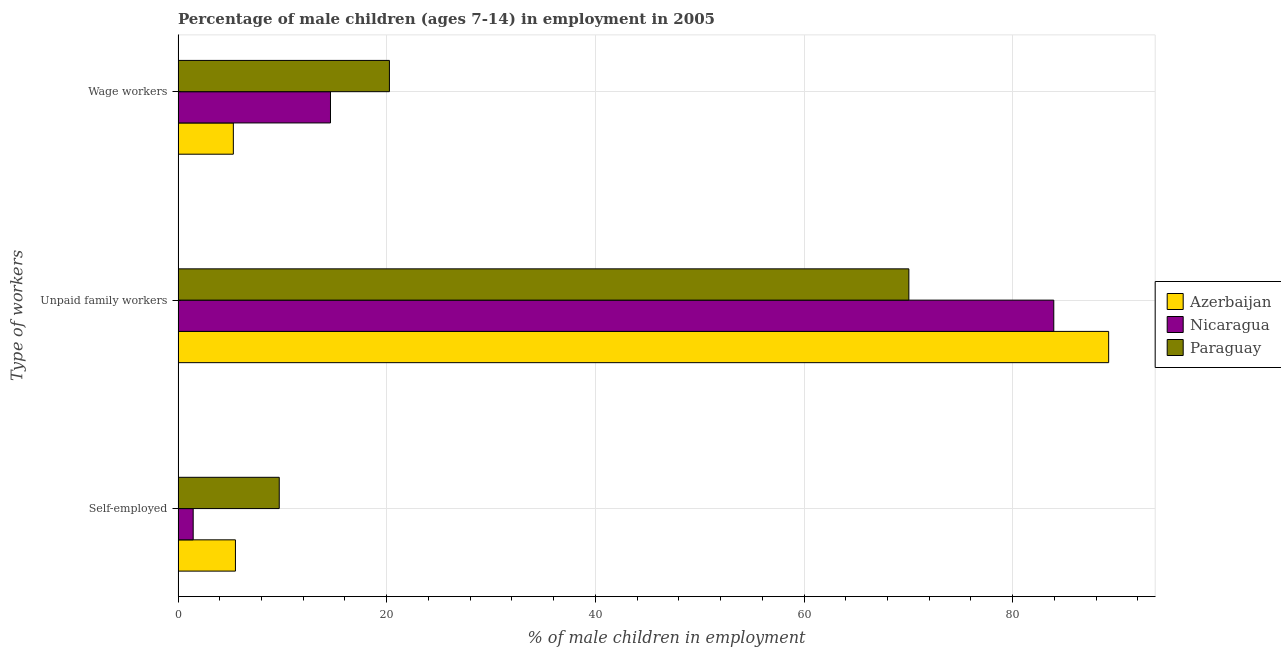How many different coloured bars are there?
Your response must be concise. 3. Are the number of bars per tick equal to the number of legend labels?
Offer a very short reply. Yes. Are the number of bars on each tick of the Y-axis equal?
Provide a short and direct response. Yes. How many bars are there on the 3rd tick from the bottom?
Offer a very short reply. 3. What is the label of the 1st group of bars from the top?
Provide a short and direct response. Wage workers. What is the percentage of children employed as unpaid family workers in Azerbaijan?
Offer a terse response. 89.2. Across all countries, what is the maximum percentage of children employed as unpaid family workers?
Your answer should be compact. 89.2. Across all countries, what is the minimum percentage of self employed children?
Your response must be concise. 1.45. In which country was the percentage of self employed children maximum?
Offer a terse response. Paraguay. In which country was the percentage of children employed as wage workers minimum?
Keep it short and to the point. Azerbaijan. What is the total percentage of children employed as wage workers in the graph?
Give a very brief answer. 40.17. What is the difference between the percentage of children employed as unpaid family workers in Paraguay and that in Nicaragua?
Provide a succinct answer. -13.89. What is the difference between the percentage of children employed as wage workers in Paraguay and the percentage of self employed children in Azerbaijan?
Provide a succinct answer. 14.76. What is the average percentage of self employed children per country?
Provide a short and direct response. 5.55. What is the difference between the percentage of children employed as wage workers and percentage of self employed children in Nicaragua?
Ensure brevity in your answer.  13.16. In how many countries, is the percentage of children employed as wage workers greater than 28 %?
Offer a terse response. 0. What is the ratio of the percentage of children employed as unpaid family workers in Paraguay to that in Azerbaijan?
Your response must be concise. 0.79. Is the difference between the percentage of children employed as unpaid family workers in Azerbaijan and Paraguay greater than the difference between the percentage of self employed children in Azerbaijan and Paraguay?
Keep it short and to the point. Yes. What is the difference between the highest and the second highest percentage of self employed children?
Provide a succinct answer. 4.2. What is the difference between the highest and the lowest percentage of children employed as wage workers?
Your answer should be compact. 14.96. What does the 3rd bar from the top in Unpaid family workers represents?
Your response must be concise. Azerbaijan. What does the 1st bar from the bottom in Self-employed represents?
Ensure brevity in your answer.  Azerbaijan. Is it the case that in every country, the sum of the percentage of self employed children and percentage of children employed as unpaid family workers is greater than the percentage of children employed as wage workers?
Your answer should be very brief. Yes. Are all the bars in the graph horizontal?
Provide a succinct answer. Yes. Are the values on the major ticks of X-axis written in scientific E-notation?
Your answer should be compact. No. Where does the legend appear in the graph?
Provide a short and direct response. Center right. What is the title of the graph?
Your answer should be compact. Percentage of male children (ages 7-14) in employment in 2005. Does "Bhutan" appear as one of the legend labels in the graph?
Your answer should be very brief. No. What is the label or title of the X-axis?
Make the answer very short. % of male children in employment. What is the label or title of the Y-axis?
Make the answer very short. Type of workers. What is the % of male children in employment in Nicaragua in Self-employed?
Provide a succinct answer. 1.45. What is the % of male children in employment in Azerbaijan in Unpaid family workers?
Offer a terse response. 89.2. What is the % of male children in employment in Nicaragua in Unpaid family workers?
Keep it short and to the point. 83.94. What is the % of male children in employment in Paraguay in Unpaid family workers?
Offer a terse response. 70.05. What is the % of male children in employment in Azerbaijan in Wage workers?
Offer a very short reply. 5.3. What is the % of male children in employment of Nicaragua in Wage workers?
Ensure brevity in your answer.  14.61. What is the % of male children in employment in Paraguay in Wage workers?
Keep it short and to the point. 20.26. Across all Type of workers, what is the maximum % of male children in employment of Azerbaijan?
Provide a succinct answer. 89.2. Across all Type of workers, what is the maximum % of male children in employment of Nicaragua?
Keep it short and to the point. 83.94. Across all Type of workers, what is the maximum % of male children in employment in Paraguay?
Offer a very short reply. 70.05. Across all Type of workers, what is the minimum % of male children in employment in Azerbaijan?
Give a very brief answer. 5.3. Across all Type of workers, what is the minimum % of male children in employment of Nicaragua?
Provide a short and direct response. 1.45. What is the total % of male children in employment in Paraguay in the graph?
Provide a short and direct response. 100.01. What is the difference between the % of male children in employment of Azerbaijan in Self-employed and that in Unpaid family workers?
Ensure brevity in your answer.  -83.7. What is the difference between the % of male children in employment of Nicaragua in Self-employed and that in Unpaid family workers?
Your answer should be compact. -82.49. What is the difference between the % of male children in employment in Paraguay in Self-employed and that in Unpaid family workers?
Your response must be concise. -60.35. What is the difference between the % of male children in employment of Nicaragua in Self-employed and that in Wage workers?
Keep it short and to the point. -13.16. What is the difference between the % of male children in employment of Paraguay in Self-employed and that in Wage workers?
Make the answer very short. -10.56. What is the difference between the % of male children in employment of Azerbaijan in Unpaid family workers and that in Wage workers?
Ensure brevity in your answer.  83.9. What is the difference between the % of male children in employment in Nicaragua in Unpaid family workers and that in Wage workers?
Your answer should be very brief. 69.33. What is the difference between the % of male children in employment of Paraguay in Unpaid family workers and that in Wage workers?
Your answer should be very brief. 49.79. What is the difference between the % of male children in employment in Azerbaijan in Self-employed and the % of male children in employment in Nicaragua in Unpaid family workers?
Give a very brief answer. -78.44. What is the difference between the % of male children in employment in Azerbaijan in Self-employed and the % of male children in employment in Paraguay in Unpaid family workers?
Offer a terse response. -64.55. What is the difference between the % of male children in employment of Nicaragua in Self-employed and the % of male children in employment of Paraguay in Unpaid family workers?
Provide a succinct answer. -68.6. What is the difference between the % of male children in employment of Azerbaijan in Self-employed and the % of male children in employment of Nicaragua in Wage workers?
Give a very brief answer. -9.11. What is the difference between the % of male children in employment of Azerbaijan in Self-employed and the % of male children in employment of Paraguay in Wage workers?
Your response must be concise. -14.76. What is the difference between the % of male children in employment in Nicaragua in Self-employed and the % of male children in employment in Paraguay in Wage workers?
Keep it short and to the point. -18.81. What is the difference between the % of male children in employment in Azerbaijan in Unpaid family workers and the % of male children in employment in Nicaragua in Wage workers?
Provide a succinct answer. 74.59. What is the difference between the % of male children in employment in Azerbaijan in Unpaid family workers and the % of male children in employment in Paraguay in Wage workers?
Your answer should be compact. 68.94. What is the difference between the % of male children in employment of Nicaragua in Unpaid family workers and the % of male children in employment of Paraguay in Wage workers?
Your answer should be compact. 63.68. What is the average % of male children in employment in Azerbaijan per Type of workers?
Offer a very short reply. 33.33. What is the average % of male children in employment of Nicaragua per Type of workers?
Offer a terse response. 33.33. What is the average % of male children in employment of Paraguay per Type of workers?
Your answer should be compact. 33.34. What is the difference between the % of male children in employment of Azerbaijan and % of male children in employment of Nicaragua in Self-employed?
Provide a succinct answer. 4.05. What is the difference between the % of male children in employment in Nicaragua and % of male children in employment in Paraguay in Self-employed?
Give a very brief answer. -8.25. What is the difference between the % of male children in employment in Azerbaijan and % of male children in employment in Nicaragua in Unpaid family workers?
Ensure brevity in your answer.  5.26. What is the difference between the % of male children in employment in Azerbaijan and % of male children in employment in Paraguay in Unpaid family workers?
Your response must be concise. 19.15. What is the difference between the % of male children in employment in Nicaragua and % of male children in employment in Paraguay in Unpaid family workers?
Offer a very short reply. 13.89. What is the difference between the % of male children in employment in Azerbaijan and % of male children in employment in Nicaragua in Wage workers?
Offer a terse response. -9.31. What is the difference between the % of male children in employment of Azerbaijan and % of male children in employment of Paraguay in Wage workers?
Provide a short and direct response. -14.96. What is the difference between the % of male children in employment in Nicaragua and % of male children in employment in Paraguay in Wage workers?
Provide a succinct answer. -5.65. What is the ratio of the % of male children in employment in Azerbaijan in Self-employed to that in Unpaid family workers?
Your response must be concise. 0.06. What is the ratio of the % of male children in employment in Nicaragua in Self-employed to that in Unpaid family workers?
Make the answer very short. 0.02. What is the ratio of the % of male children in employment of Paraguay in Self-employed to that in Unpaid family workers?
Make the answer very short. 0.14. What is the ratio of the % of male children in employment of Azerbaijan in Self-employed to that in Wage workers?
Keep it short and to the point. 1.04. What is the ratio of the % of male children in employment in Nicaragua in Self-employed to that in Wage workers?
Give a very brief answer. 0.1. What is the ratio of the % of male children in employment in Paraguay in Self-employed to that in Wage workers?
Make the answer very short. 0.48. What is the ratio of the % of male children in employment in Azerbaijan in Unpaid family workers to that in Wage workers?
Offer a very short reply. 16.83. What is the ratio of the % of male children in employment in Nicaragua in Unpaid family workers to that in Wage workers?
Offer a terse response. 5.75. What is the ratio of the % of male children in employment in Paraguay in Unpaid family workers to that in Wage workers?
Provide a succinct answer. 3.46. What is the difference between the highest and the second highest % of male children in employment in Azerbaijan?
Offer a very short reply. 83.7. What is the difference between the highest and the second highest % of male children in employment in Nicaragua?
Offer a very short reply. 69.33. What is the difference between the highest and the second highest % of male children in employment in Paraguay?
Offer a terse response. 49.79. What is the difference between the highest and the lowest % of male children in employment of Azerbaijan?
Keep it short and to the point. 83.9. What is the difference between the highest and the lowest % of male children in employment in Nicaragua?
Keep it short and to the point. 82.49. What is the difference between the highest and the lowest % of male children in employment in Paraguay?
Offer a terse response. 60.35. 